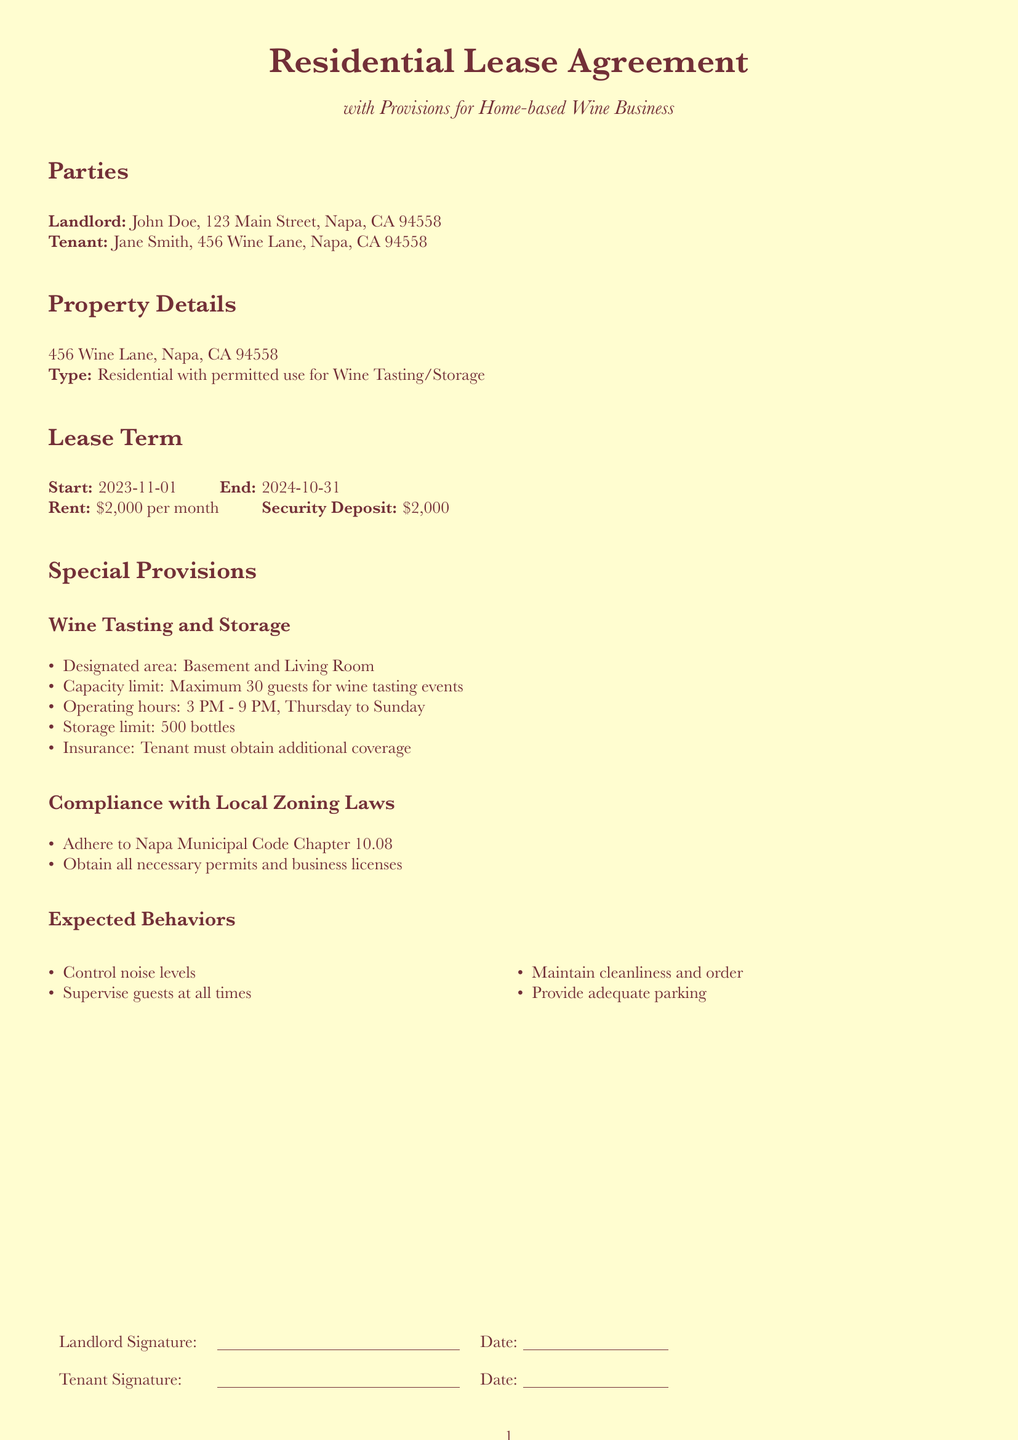What is the property address? The property address can be found in the Property Details section of the document.
Answer: 456 Wine Lane, Napa, CA 94558 Who is the landlord? The landlord's name is provided in the Parties section of the document.
Answer: John Doe What is the monthly rent? The monthly rent is stated in the Lease Term section of the document.
Answer: $2,000 What is the maximum guest capacity for wine tasting events? The maximum guest capacity is mentioned in the Special Provisions under Wine Tasting and Storage.
Answer: Maximum 30 guests Which days are allowed for hosting wine tastings? The operating days for wine tastings are specified under Special Provisions.
Answer: Thursday to Sunday What is the insurance requirement for the tenant? The insurance requirement can be found in the Special Provisions section.
Answer: Tenant must obtain additional coverage Which local code must be adhered to? The local code is referenced in the Compliance with Local Zoning Laws section.
Answer: Napa Municipal Code Chapter 10.08 What is the storage bottle limit? The storage limit is listed in the Wine Tasting and Storage special provisions.
Answer: 500 bottles What is the lease end date? The lease end date is specified in the Lease Term section.
Answer: 2024-10-31 